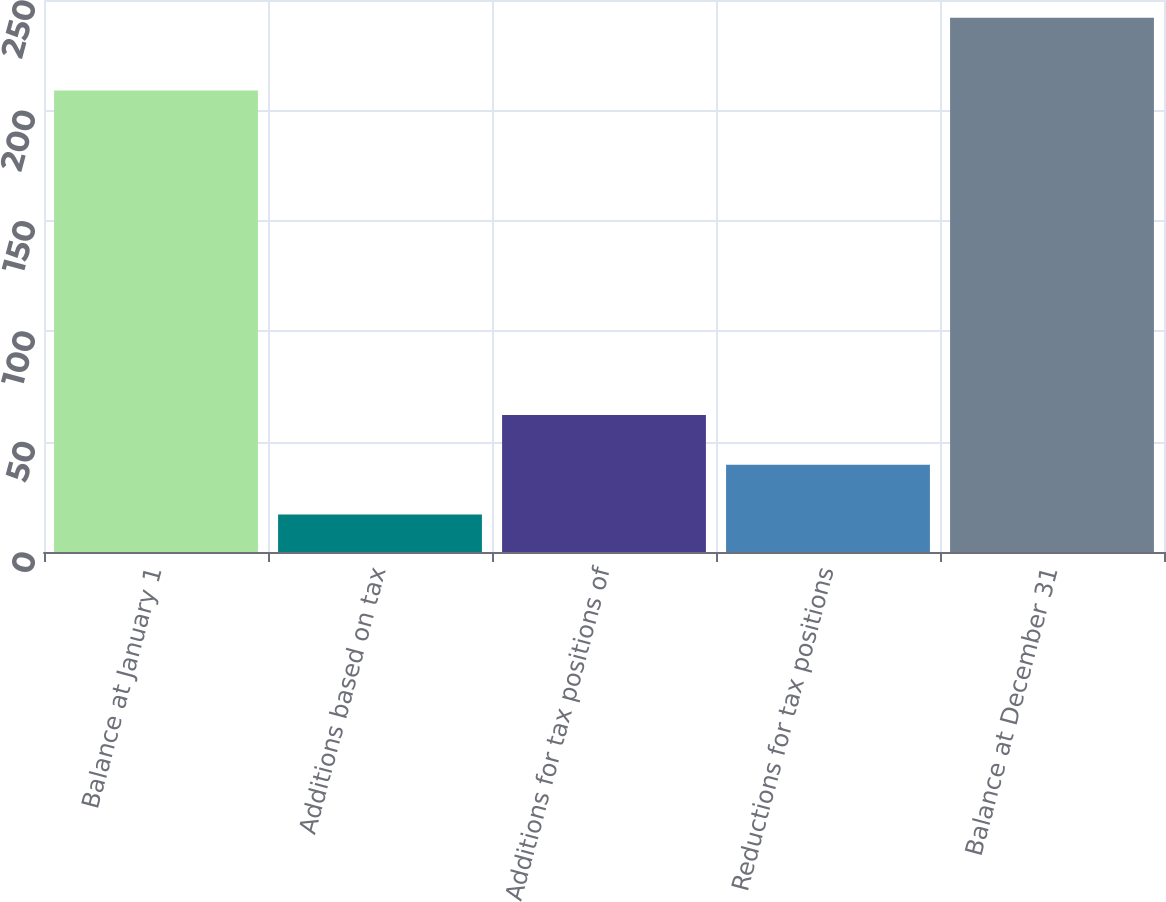Convert chart. <chart><loc_0><loc_0><loc_500><loc_500><bar_chart><fcel>Balance at January 1<fcel>Additions based on tax<fcel>Additions for tax positions of<fcel>Reductions for tax positions<fcel>Balance at December 31<nl><fcel>209<fcel>17<fcel>62<fcel>39.5<fcel>242<nl></chart> 